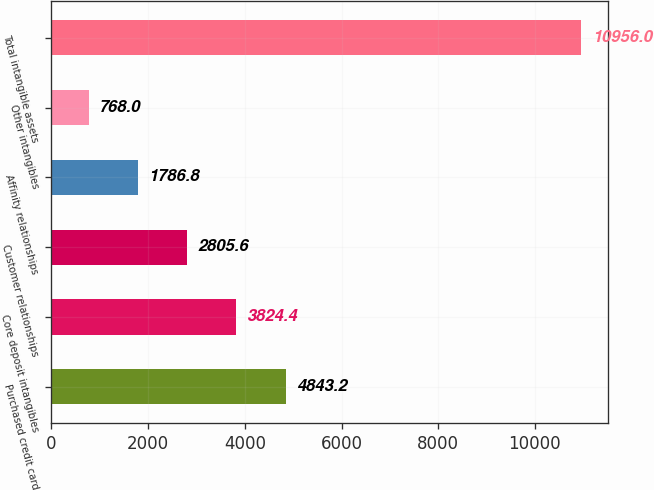Convert chart to OTSL. <chart><loc_0><loc_0><loc_500><loc_500><bar_chart><fcel>Purchased credit card<fcel>Core deposit intangibles<fcel>Customer relationships<fcel>Affinity relationships<fcel>Other intangibles<fcel>Total intangible assets<nl><fcel>4843.2<fcel>3824.4<fcel>2805.6<fcel>1786.8<fcel>768<fcel>10956<nl></chart> 